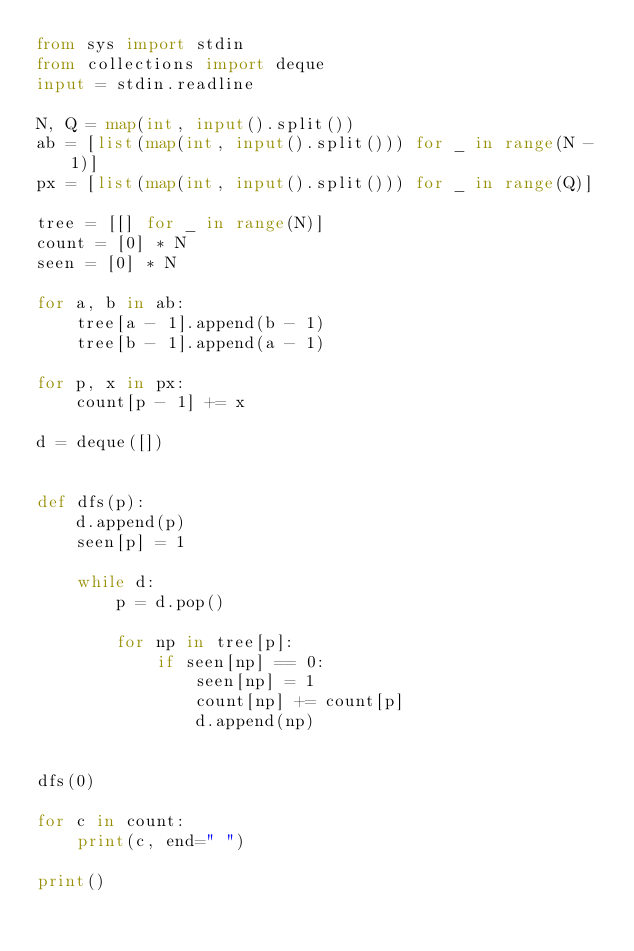<code> <loc_0><loc_0><loc_500><loc_500><_Python_>from sys import stdin
from collections import deque
input = stdin.readline

N, Q = map(int, input().split())
ab = [list(map(int, input().split())) for _ in range(N - 1)]
px = [list(map(int, input().split())) for _ in range(Q)]

tree = [[] for _ in range(N)]
count = [0] * N
seen = [0] * N

for a, b in ab:
    tree[a - 1].append(b - 1)
    tree[b - 1].append(a - 1)

for p, x in px:
    count[p - 1] += x

d = deque([])


def dfs(p):
    d.append(p)
    seen[p] = 1

    while d:
        p = d.pop()

        for np in tree[p]:
            if seen[np] == 0:
                seen[np] = 1
                count[np] += count[p]
                d.append(np)


dfs(0)

for c in count:
    print(c, end=" ")

print()
</code> 